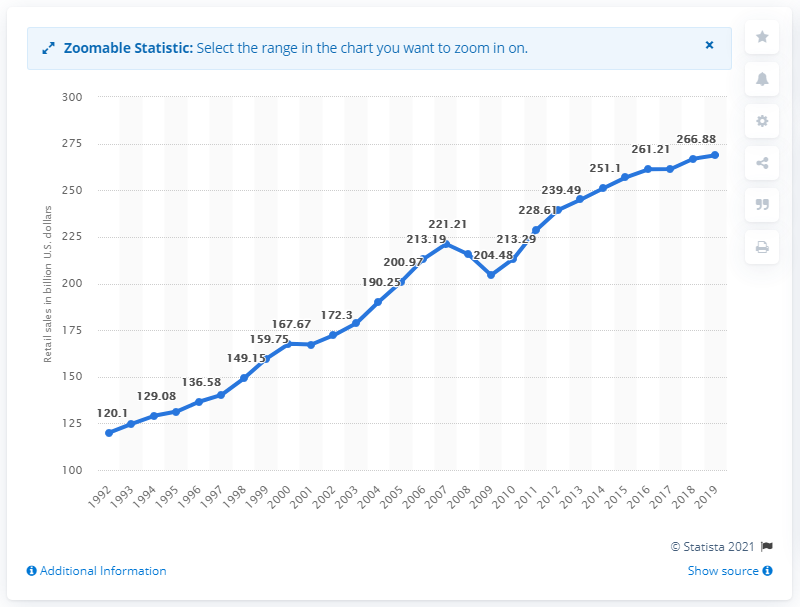Draw attention to some important aspects in this diagram. In 2019, the sales of clothing and clothing accessories stores in the United States totaled 268.74 billion U.S. dollars. 